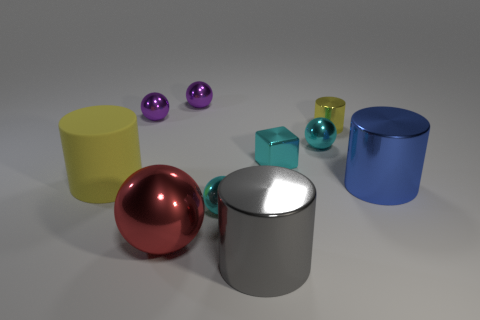There is a large cylinder that is the same color as the tiny cylinder; what is it made of?
Provide a succinct answer. Rubber. What number of things are behind the small cyan object to the left of the block?
Your answer should be very brief. 7. Does the thing that is on the right side of the yellow metal thing have the same color as the metal cylinder that is to the left of the small yellow metal object?
Provide a short and direct response. No. What is the material of the blue thing that is the same size as the rubber cylinder?
Provide a succinct answer. Metal. The big shiny thing that is left of the small cyan object on the left side of the big cylinder in front of the blue cylinder is what shape?
Offer a very short reply. Sphere. There is a red thing that is the same size as the blue cylinder; what is its shape?
Your answer should be very brief. Sphere. There is a large thing on the right side of the shiny cylinder behind the small cyan block; what number of big yellow things are in front of it?
Make the answer very short. 0. Are there more small metallic things that are to the right of the big blue cylinder than large gray cylinders that are in front of the large gray cylinder?
Keep it short and to the point. No. What number of other large things are the same shape as the big gray shiny object?
Make the answer very short. 2. How many objects are either tiny cyan metal things in front of the big blue thing or big cylinders that are left of the red sphere?
Ensure brevity in your answer.  2. 